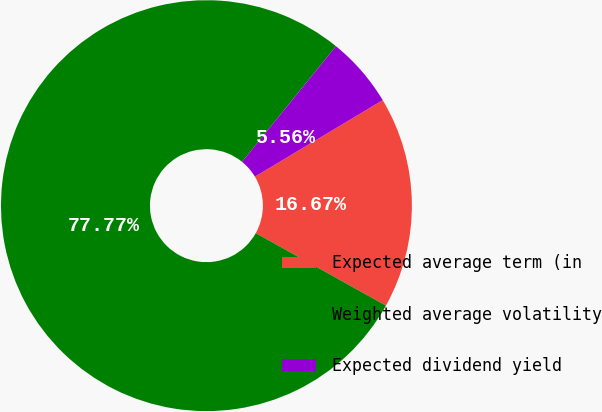Convert chart to OTSL. <chart><loc_0><loc_0><loc_500><loc_500><pie_chart><fcel>Expected average term (in<fcel>Weighted average volatility<fcel>Expected dividend yield<nl><fcel>16.67%<fcel>77.78%<fcel>5.56%<nl></chart> 